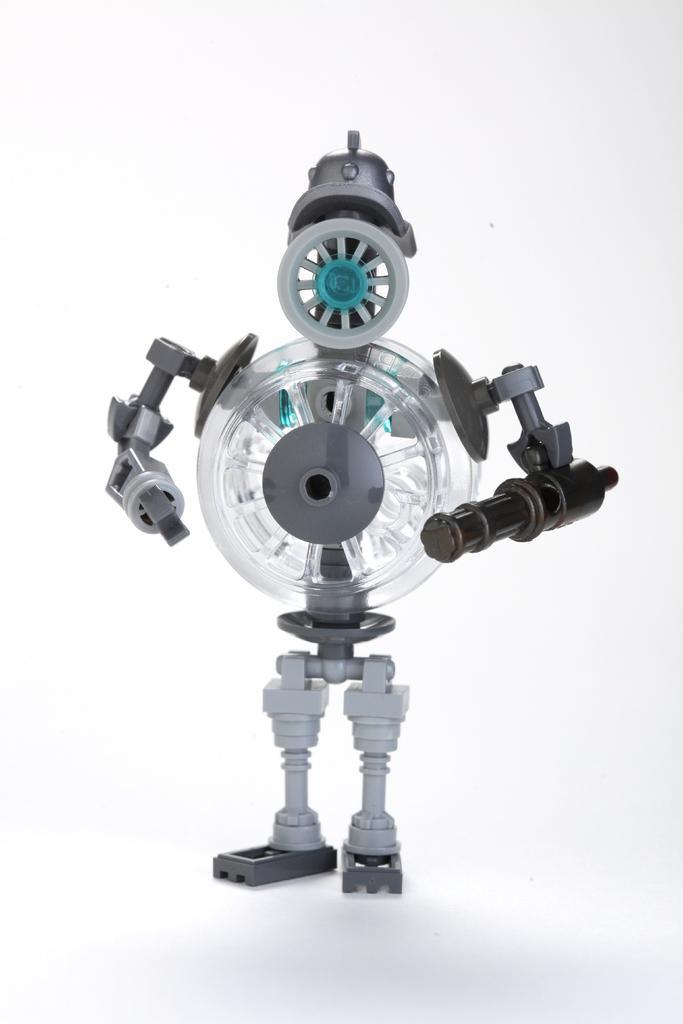Describe this image in one or two sentences. In this image we can see a robot and the background is white. 